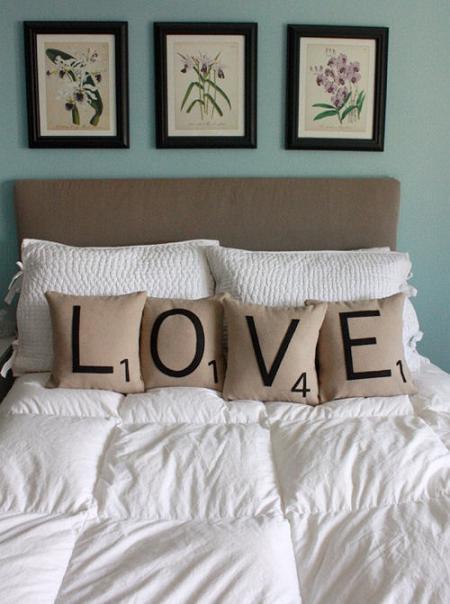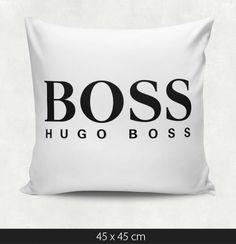The first image is the image on the left, the second image is the image on the right. Evaluate the accuracy of this statement regarding the images: "The right image contains exactly two pillows.". Is it true? Answer yes or no. No. The first image is the image on the left, the second image is the image on the right. Evaluate the accuracy of this statement regarding the images: "One image features a pillow design with a spoon pictured as well as black text, and the other image shows two rectangular white pillows with black text.". Is it true? Answer yes or no. No. 